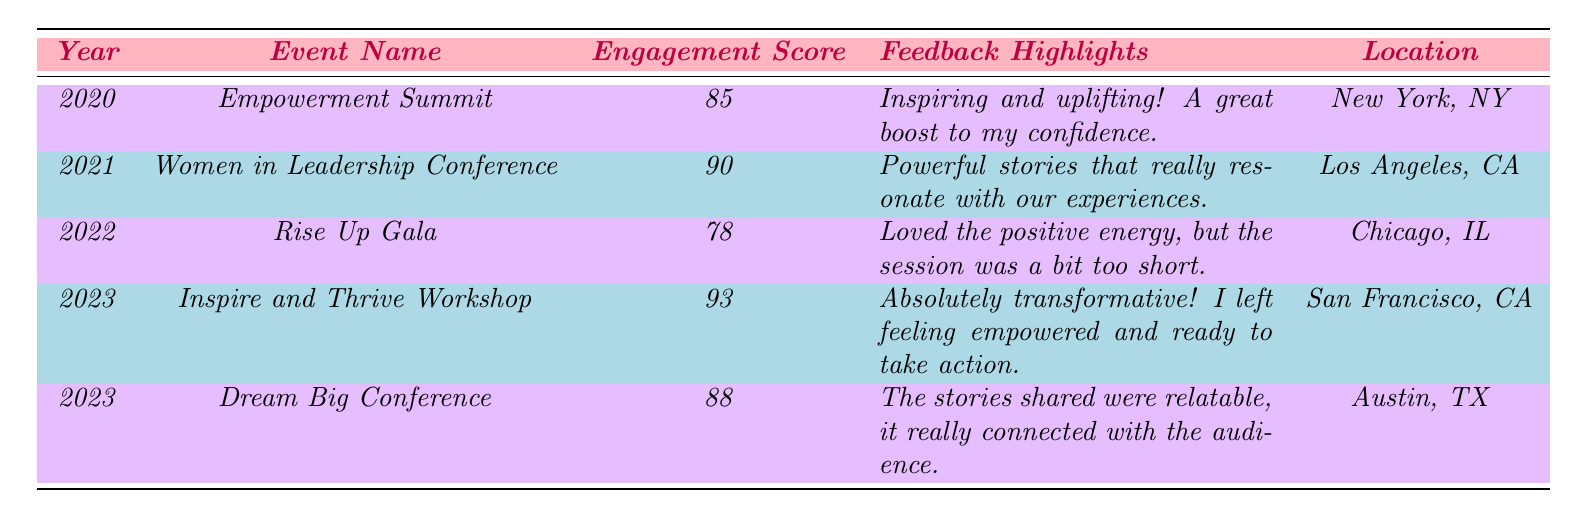What was the audience engagement score for the Empowerment Summit in 2020? The score is directly listed in the table under the appropriate year and event, which shows a score of 85 for the Empowerment Summit in 2020.
Answer: 85 Which event had the highest audience engagement score? By comparing the scores listed for each event, the Inspire and Thrive Workshop in 2023 recorded the highest score of 93.
Answer: Inspire and Thrive Workshop What is the average audience engagement score for the events in 2023? The scores for 2023 are 93 and 88. Summing them gives 181. The average is calculated by dividing 181 by 2, resulting in 90.5.
Answer: 90.5 Did the audience engagement score increase from 2020 to 2021? The score for 2020 was 85, and it rose to 90 in 2021; hence, the score did increase.
Answer: Yes What feedback comment was given for the Rise Up Gala in 2022? The feedback highlighted in the table specifically mentions enjoying the positive energy but felt that the session was a bit too short.
Answer: Loved the positive energy, but the session was too short How many events listed took place in 2023? There are two entries for 2023 in the table, indicating that there were two events held that year: the Inspire and Thrive Workshop and the Dream Big Conference.
Answer: 2 Which location had an event with an engagement score of 78? The Rise Up Gala in Chicago, IL had an audience engagement score of 78.
Answer: Chicago, IL What was the demographic age group of the audience for the Women in Leadership Conference? The table specifies that the audience demographic age group for this event in 2021 was 26-35.
Answer: 26-35 Calculate the difference in audience engagement scores between the Women in Leadership Conference and the Rise Up Gala. The score for Women in Leadership Conference is 90, and for Rise Up Gala, it is 78. The difference is 90 - 78 = 12.
Answer: 12 Is it true that all feedback comments were positive? Reviewing the feedback comments, while many are enthusiastic, the Rise Up Gala feedback indicates it was enjoyable but pointed out a shortcoming of the session length, suggesting not all comments were entirely positive.
Answer: No 